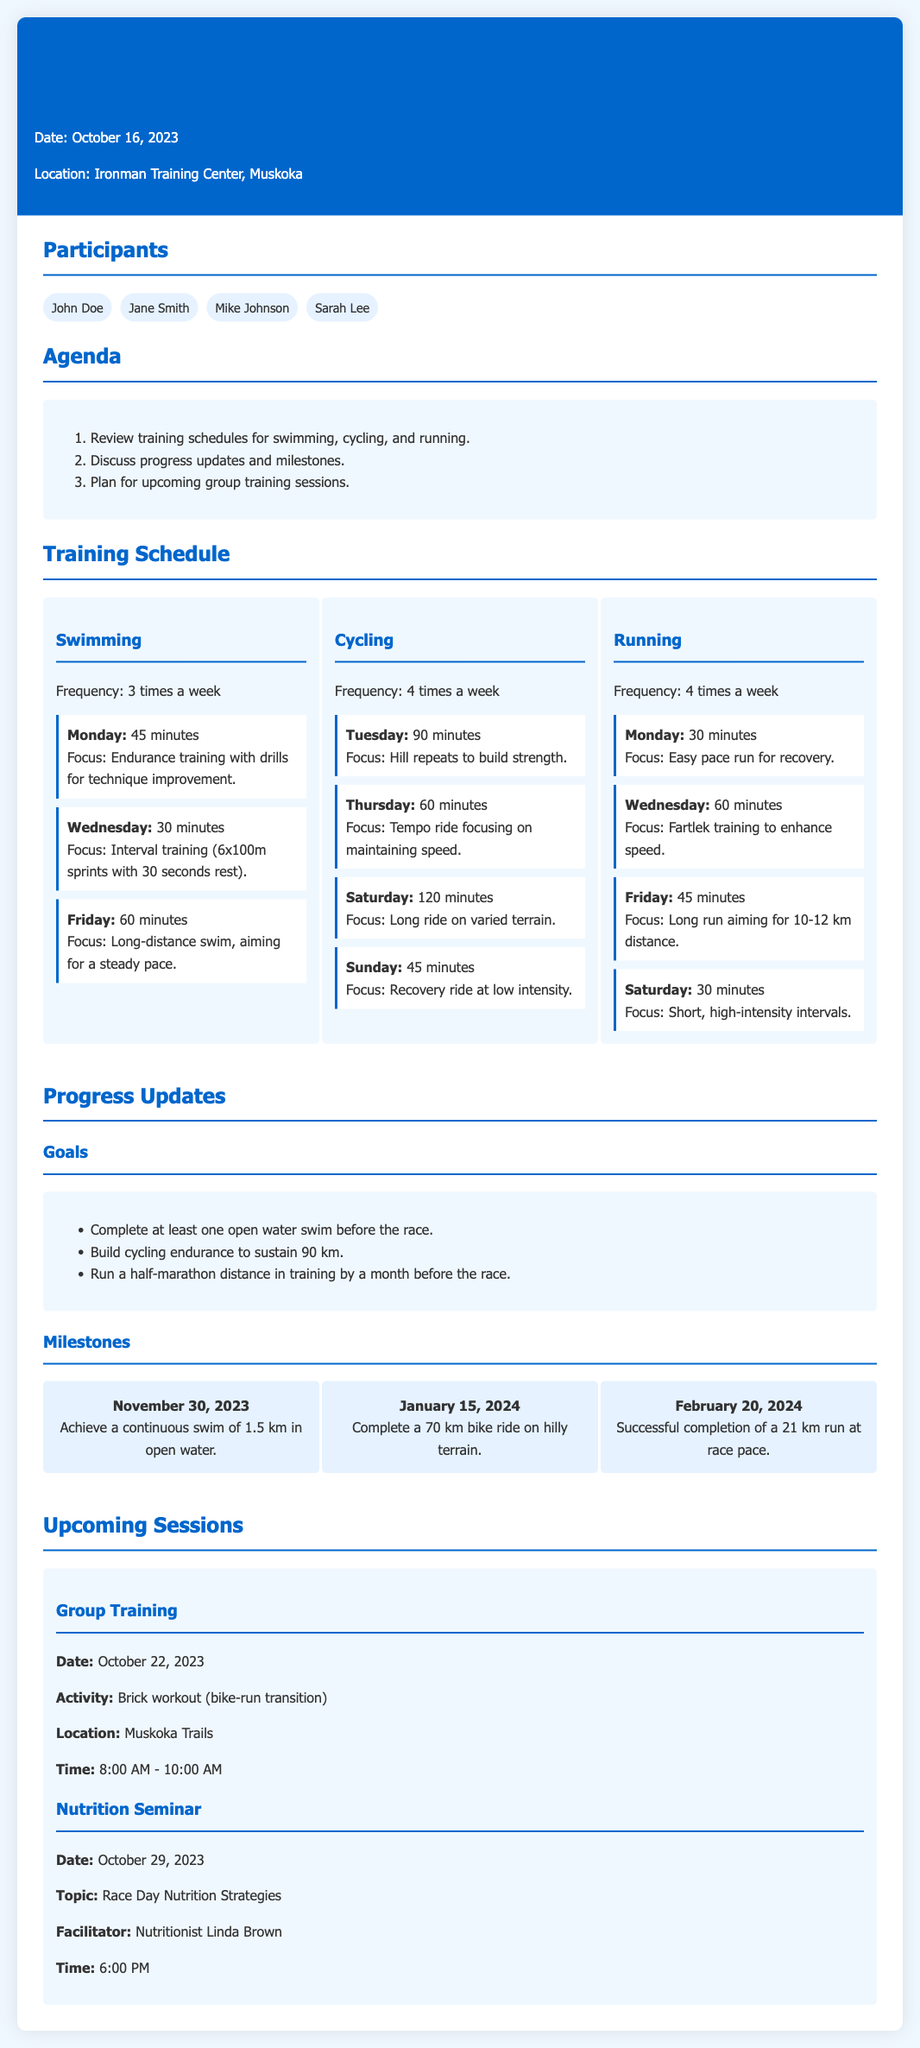What date was the meeting held? The date of the meeting is explicitly mentioned in the header of the document, which is October 16, 2023.
Answer: October 16, 2023 How many times a week is swimming scheduled? The frequency of swimming sessions is stated in the swimming section of the training schedule, which is 3 times a week.
Answer: 3 times a week What is the focus of the cycling session on Tuesday? The focus for the Tuesday cycling session is detailed in the corresponding session, which is hill repeats to build strength.
Answer: Hill repeats to build strength What milestone is set for November 30, 2023? The document specifies a milestone related to a continuous swim of 1.5 km in open water for the date November 30, 2023.
Answer: Achieve a continuous swim of 1.5 km in open water When is the next group training session scheduled? The information about the upcoming group training session is provided in the upcoming sessions section, which states it is on October 22, 2023.
Answer: October 22, 2023 